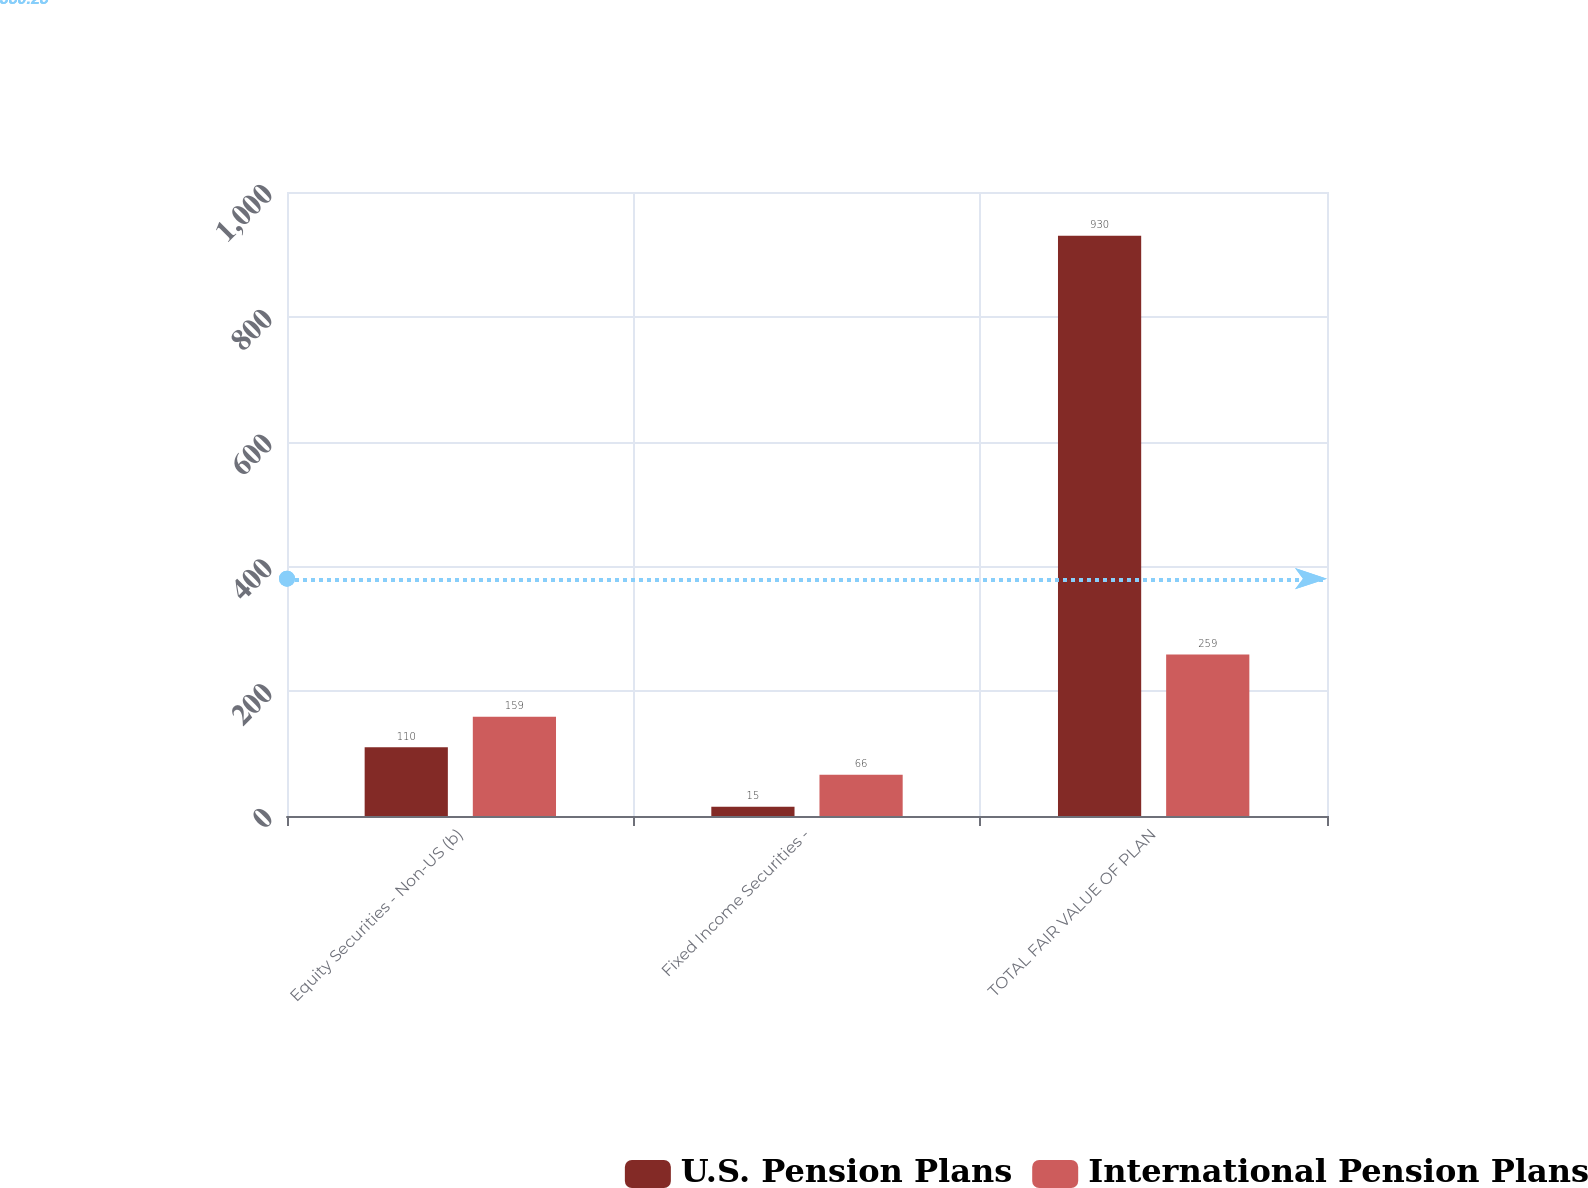Convert chart. <chart><loc_0><loc_0><loc_500><loc_500><stacked_bar_chart><ecel><fcel>Equity Securities - Non-US (b)<fcel>Fixed Income Securities -<fcel>TOTAL FAIR VALUE OF PLAN<nl><fcel>U.S. Pension Plans<fcel>110<fcel>15<fcel>930<nl><fcel>International Pension Plans<fcel>159<fcel>66<fcel>259<nl></chart> 